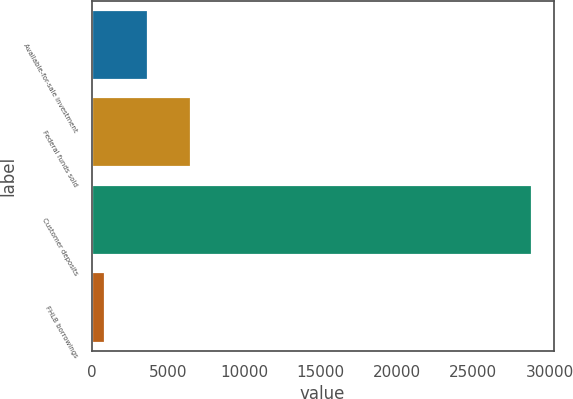Convert chart. <chart><loc_0><loc_0><loc_500><loc_500><bar_chart><fcel>Available-for-sale investment<fcel>Federal funds sold<fcel>Customer deposits<fcel>FHLB borrowings<nl><fcel>3686.4<fcel>6477.8<fcel>28809<fcel>895<nl></chart> 